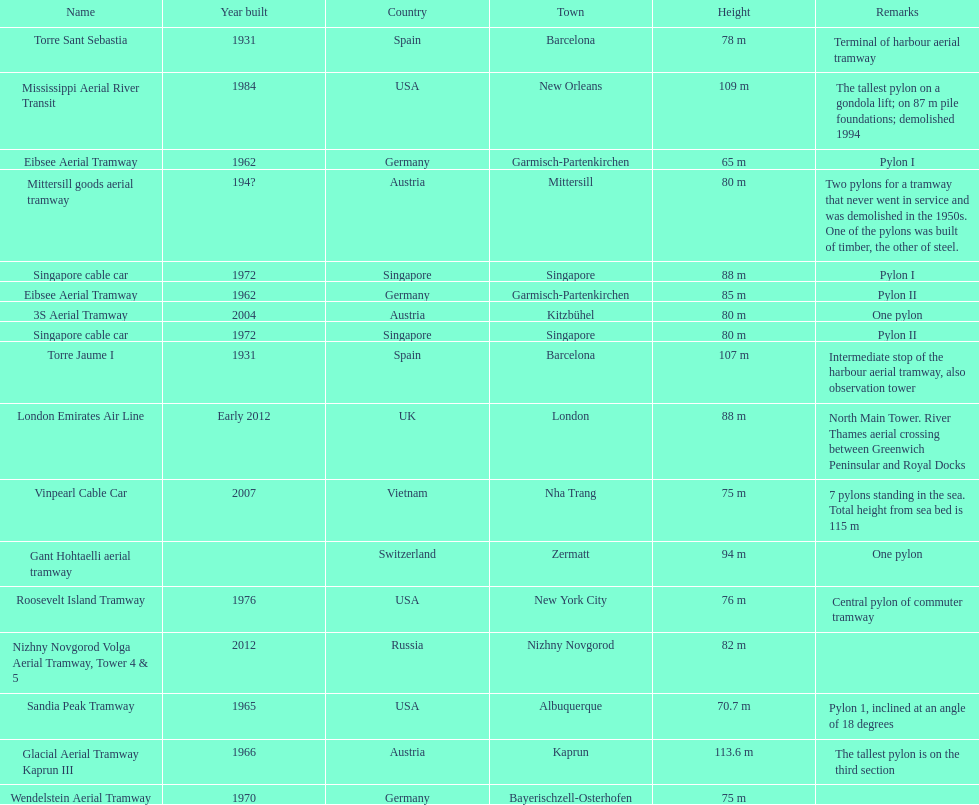The london emirates air line pylon has the same height as which pylon? Singapore cable car. 